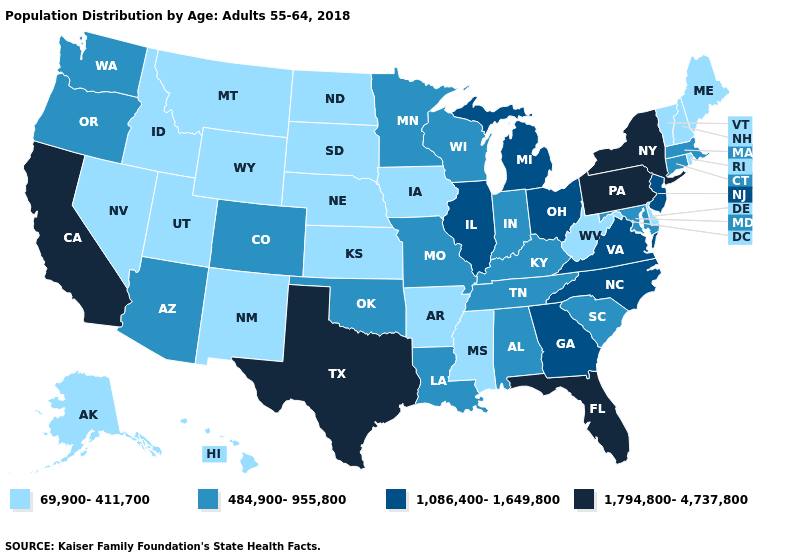What is the highest value in the USA?
Quick response, please. 1,794,800-4,737,800. Does New Mexico have the lowest value in the West?
Give a very brief answer. Yes. Among the states that border New Hampshire , which have the highest value?
Keep it brief. Massachusetts. What is the value of Minnesota?
Short answer required. 484,900-955,800. Name the states that have a value in the range 484,900-955,800?
Keep it brief. Alabama, Arizona, Colorado, Connecticut, Indiana, Kentucky, Louisiana, Maryland, Massachusetts, Minnesota, Missouri, Oklahoma, Oregon, South Carolina, Tennessee, Washington, Wisconsin. Among the states that border Kentucky , which have the lowest value?
Short answer required. West Virginia. Name the states that have a value in the range 69,900-411,700?
Quick response, please. Alaska, Arkansas, Delaware, Hawaii, Idaho, Iowa, Kansas, Maine, Mississippi, Montana, Nebraska, Nevada, New Hampshire, New Mexico, North Dakota, Rhode Island, South Dakota, Utah, Vermont, West Virginia, Wyoming. Name the states that have a value in the range 1,794,800-4,737,800?
Be succinct. California, Florida, New York, Pennsylvania, Texas. Does New Mexico have the highest value in the West?
Answer briefly. No. What is the value of Kansas?
Keep it brief. 69,900-411,700. Name the states that have a value in the range 1,086,400-1,649,800?
Be succinct. Georgia, Illinois, Michigan, New Jersey, North Carolina, Ohio, Virginia. What is the value of Idaho?
Keep it brief. 69,900-411,700. Among the states that border North Dakota , does South Dakota have the lowest value?
Answer briefly. Yes. What is the value of Oklahoma?
Concise answer only. 484,900-955,800. Name the states that have a value in the range 1,794,800-4,737,800?
Keep it brief. California, Florida, New York, Pennsylvania, Texas. 